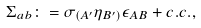<formula> <loc_0><loc_0><loc_500><loc_500>\Sigma _ { a b } \colon = { \sigma } _ { ( A ^ { \prime } } \eta _ { B ^ { \prime } ) } \epsilon _ { A B } + c . c . ,</formula> 